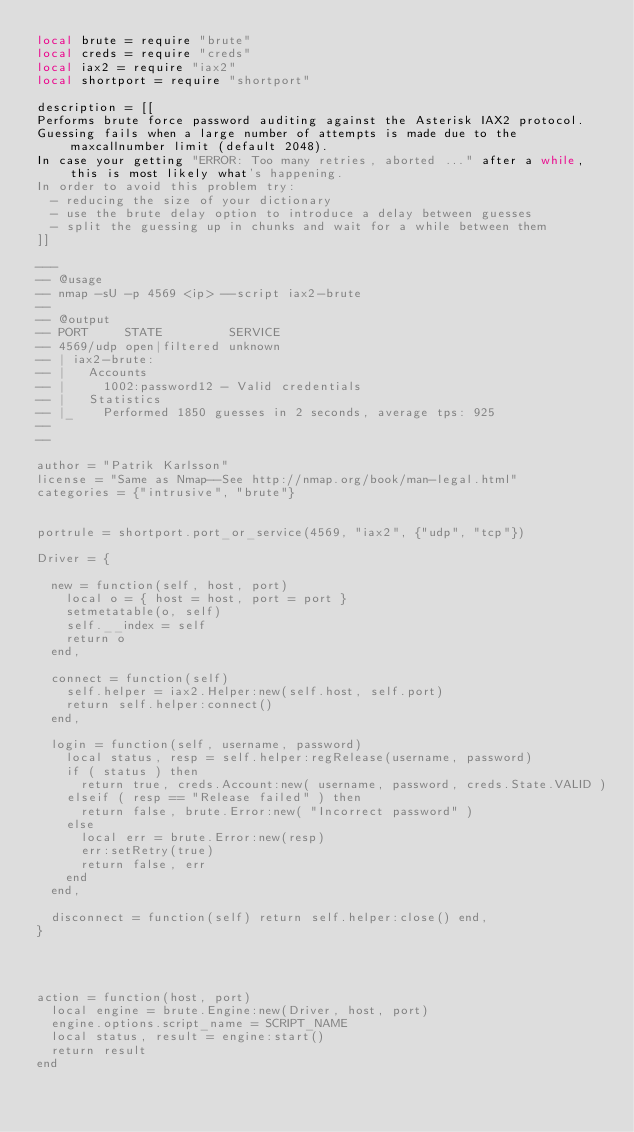Convert code to text. <code><loc_0><loc_0><loc_500><loc_500><_Lua_>local brute = require "brute"
local creds = require "creds"
local iax2 = require "iax2"
local shortport = require "shortport"

description = [[
Performs brute force password auditing against the Asterisk IAX2 protocol.
Guessing fails when a large number of attempts is made due to the maxcallnumber limit (default 2048).
In case your getting "ERROR: Too many retries, aborted ..." after a while, this is most likely what's happening.
In order to avoid this problem try:
  - reducing the size of your dictionary
  - use the brute delay option to introduce a delay between guesses
  - split the guessing up in chunks and wait for a while between them
]]

---
-- @usage
-- nmap -sU -p 4569 <ip> --script iax2-brute
--
-- @output
-- PORT     STATE         SERVICE
-- 4569/udp open|filtered unknown
-- | iax2-brute:
-- |   Accounts
-- |     1002:password12 - Valid credentials
-- |   Statistics
-- |_    Performed 1850 guesses in 2 seconds, average tps: 925
--
--

author = "Patrik Karlsson"
license = "Same as Nmap--See http://nmap.org/book/man-legal.html"
categories = {"intrusive", "brute"}


portrule = shortport.port_or_service(4569, "iax2", {"udp", "tcp"})

Driver = {

  new = function(self, host, port)
    local o = { host = host, port = port }
    setmetatable(o, self)
    self.__index = self
    return o
  end,

  connect = function(self)
    self.helper = iax2.Helper:new(self.host, self.port)
    return self.helper:connect()
  end,

  login = function(self, username, password)
    local status, resp = self.helper:regRelease(username, password)
    if ( status ) then
      return true, creds.Account:new( username, password, creds.State.VALID )
    elseif ( resp == "Release failed" ) then
      return false, brute.Error:new( "Incorrect password" )
    else
      local err = brute.Error:new(resp)
      err:setRetry(true)
      return false, err
    end
  end,

  disconnect = function(self) return self.helper:close() end,
}




action = function(host, port)
  local engine = brute.Engine:new(Driver, host, port)
  engine.options.script_name = SCRIPT_NAME
  local status, result = engine:start()
  return result
end
</code> 